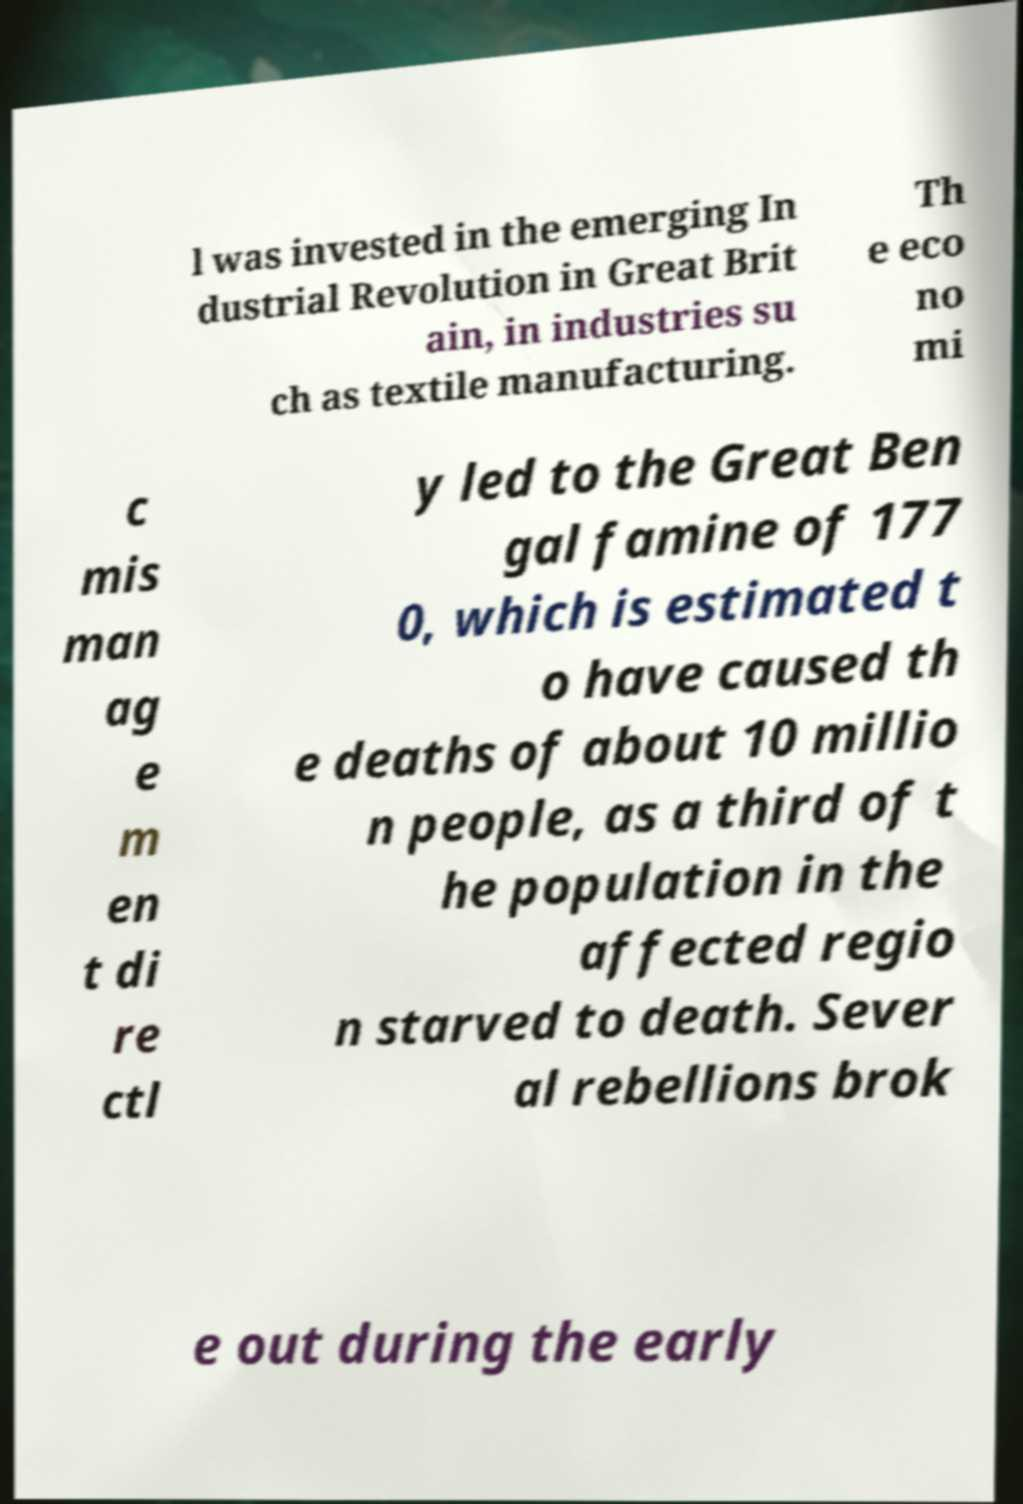Could you extract and type out the text from this image? l was invested in the emerging In dustrial Revolution in Great Brit ain, in industries su ch as textile manufacturing. Th e eco no mi c mis man ag e m en t di re ctl y led to the Great Ben gal famine of 177 0, which is estimated t o have caused th e deaths of about 10 millio n people, as a third of t he population in the affected regio n starved to death. Sever al rebellions brok e out during the early 